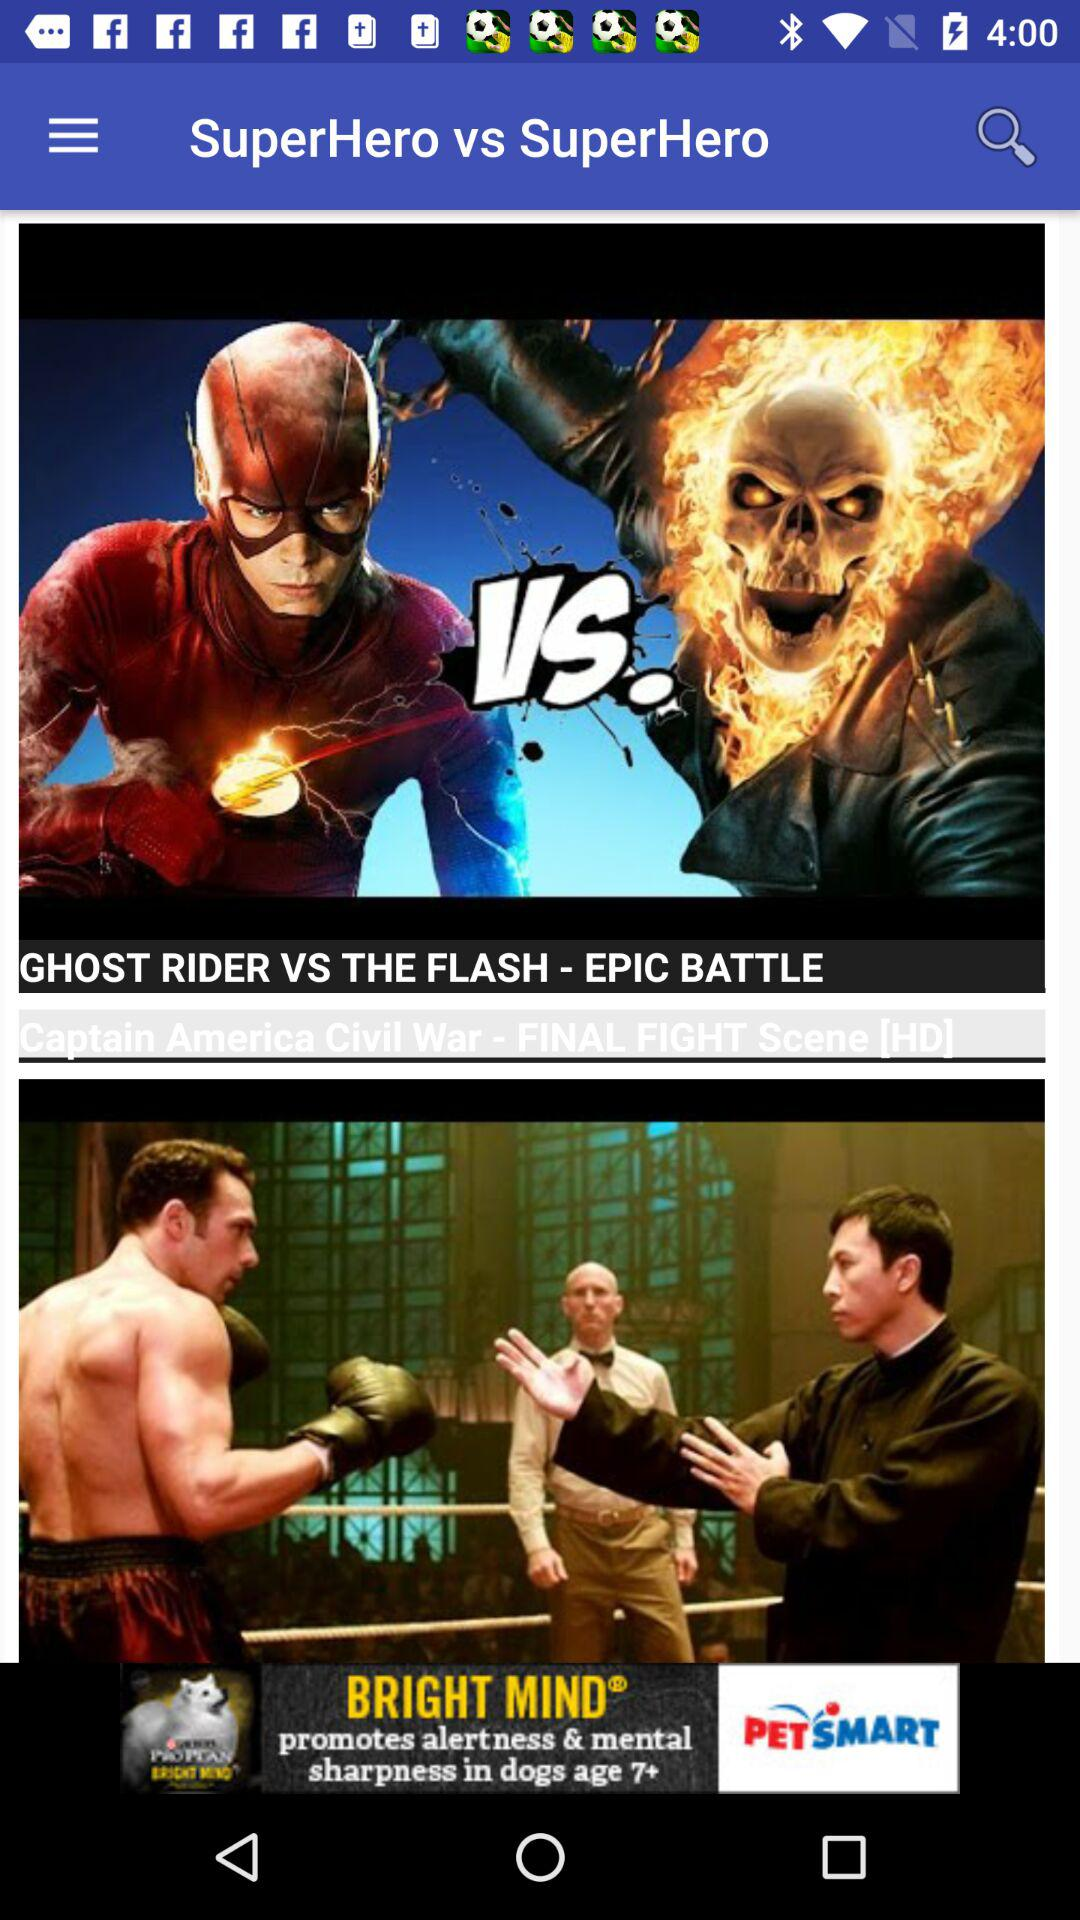What is the name of the movies? The name of the movie is "Captain America Civil War". 